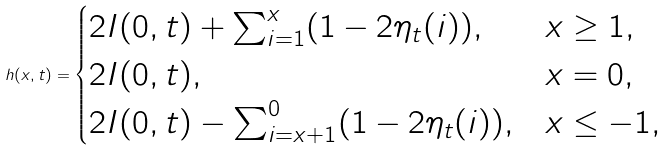<formula> <loc_0><loc_0><loc_500><loc_500>h ( x , t ) = \begin{cases} 2 I ( 0 , t ) + \sum _ { i = 1 } ^ { x } ( 1 - 2 \eta _ { t } ( i ) ) , & x \geq 1 , \\ 2 I ( 0 , t ) , & x = 0 , \\ 2 I ( 0 , t ) - \sum _ { i = x + 1 } ^ { 0 } ( 1 - 2 \eta _ { t } ( i ) ) , & x \leq - 1 , \end{cases}</formula> 